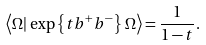Convert formula to latex. <formula><loc_0><loc_0><loc_500><loc_500>\left \langle \Omega | \, \exp \left \{ t b ^ { + } b ^ { - } \right \} \, \Omega \right \rangle = \frac { 1 } { 1 - t } .</formula> 